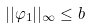<formula> <loc_0><loc_0><loc_500><loc_500>| | \varphi _ { 1 } | | _ { \infty } \leq b</formula> 